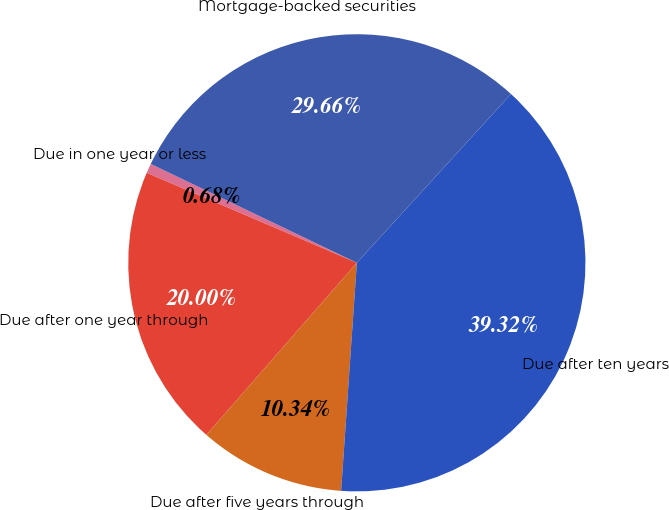<chart> <loc_0><loc_0><loc_500><loc_500><pie_chart><fcel>Due in one year or less<fcel>Due after one year through<fcel>Due after five years through<fcel>Due after ten years<fcel>Mortgage-backed securities<nl><fcel>0.68%<fcel>20.0%<fcel>10.34%<fcel>39.32%<fcel>29.66%<nl></chart> 